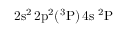<formula> <loc_0><loc_0><loc_500><loc_500>2 s ^ { 2 } \, 2 p ^ { 2 } ( ^ { 3 } P ) \, 4 s ^ { 2 } P</formula> 